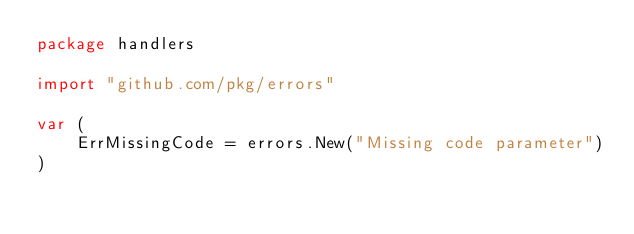<code> <loc_0><loc_0><loc_500><loc_500><_Go_>package handlers

import "github.com/pkg/errors"

var (
	ErrMissingCode = errors.New("Missing code parameter")
)
</code> 